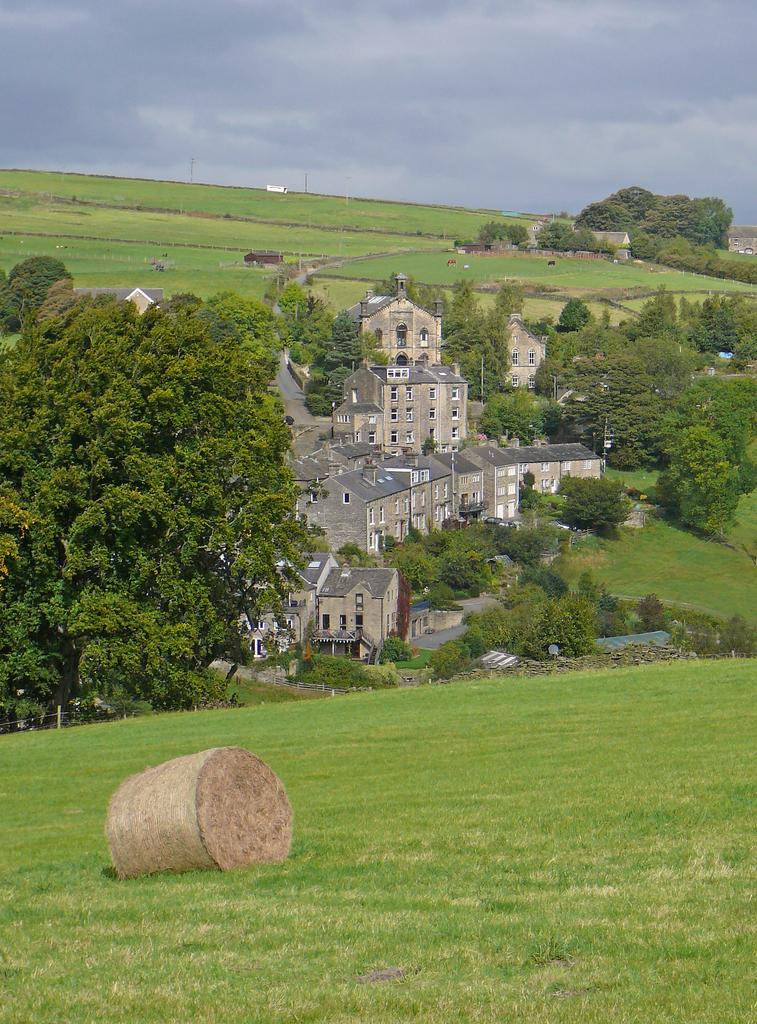What object is placed on the grass in the image? There is a wooden brick on the grass. What can be seen in the background of the image? There are trees, buildings, and the sky visible in the background of the image. What type of riddle can be solved by the wooden brick in the image? There is no riddle associated with the wooden brick in the image. How many dogs are present in the image? There are no dogs present in the image. 